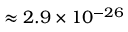<formula> <loc_0><loc_0><loc_500><loc_500>\approx 2 . 9 \times 1 0 ^ { - 2 6 }</formula> 